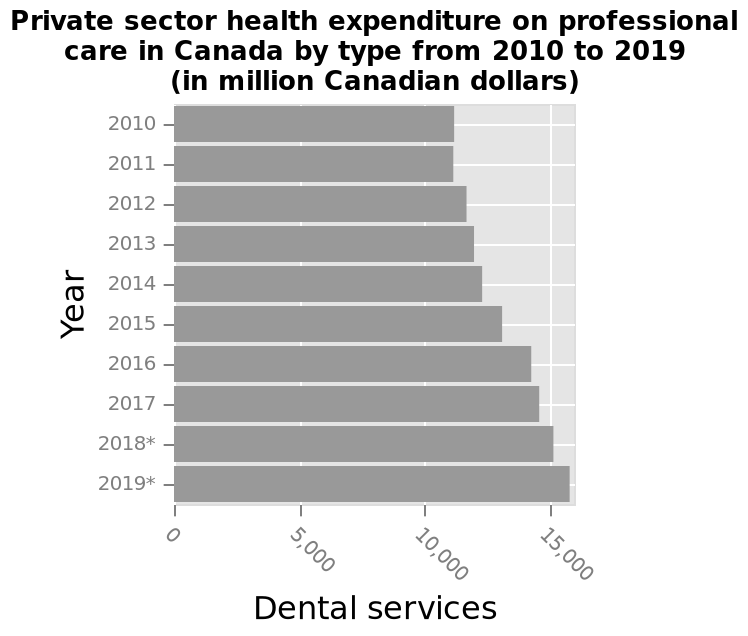<image>
What was the expenditure in 2010-2011 compared to the previous year?  The expenditure in 2010-2011 was the same as the previous year. 